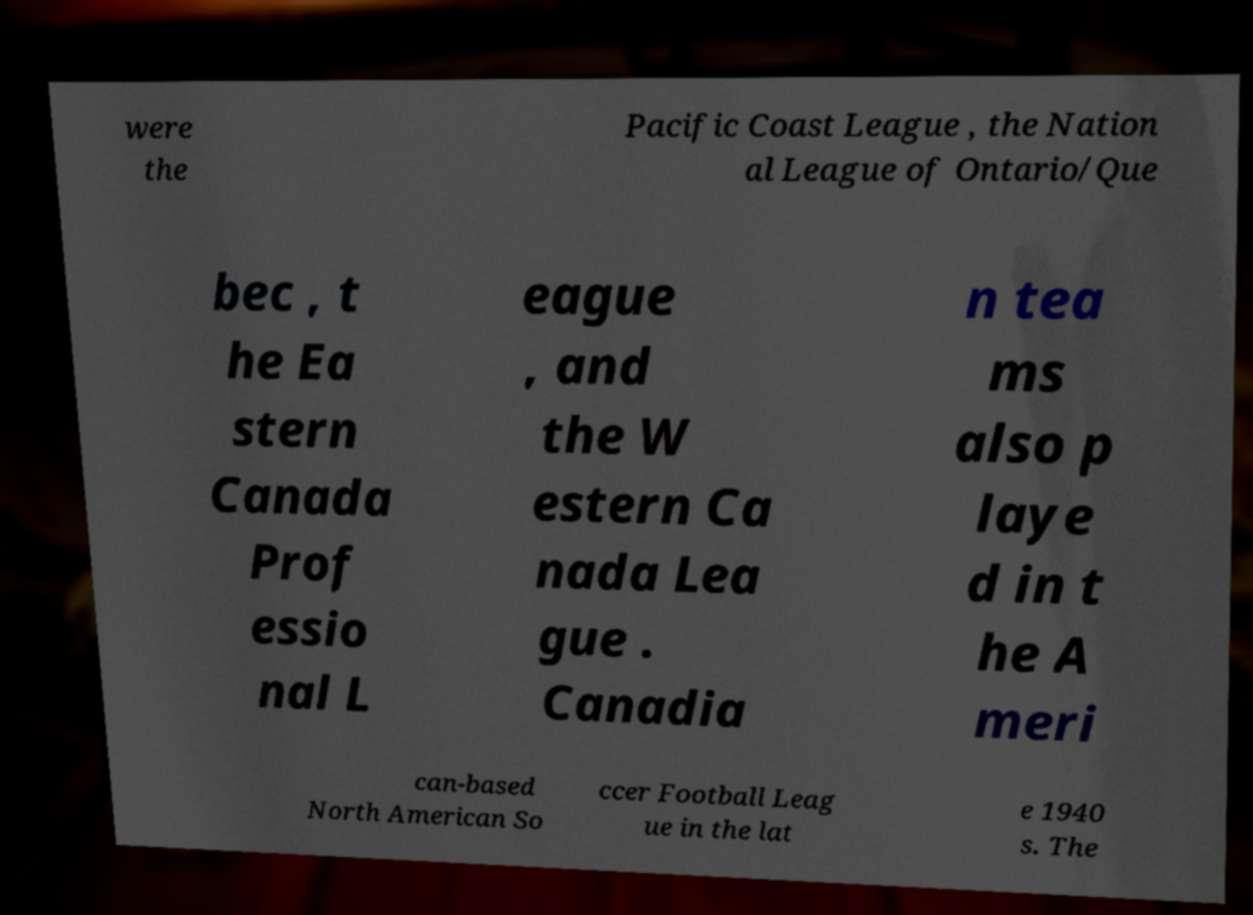Can you accurately transcribe the text from the provided image for me? were the Pacific Coast League , the Nation al League of Ontario/Que bec , t he Ea stern Canada Prof essio nal L eague , and the W estern Ca nada Lea gue . Canadia n tea ms also p laye d in t he A meri can-based North American So ccer Football Leag ue in the lat e 1940 s. The 